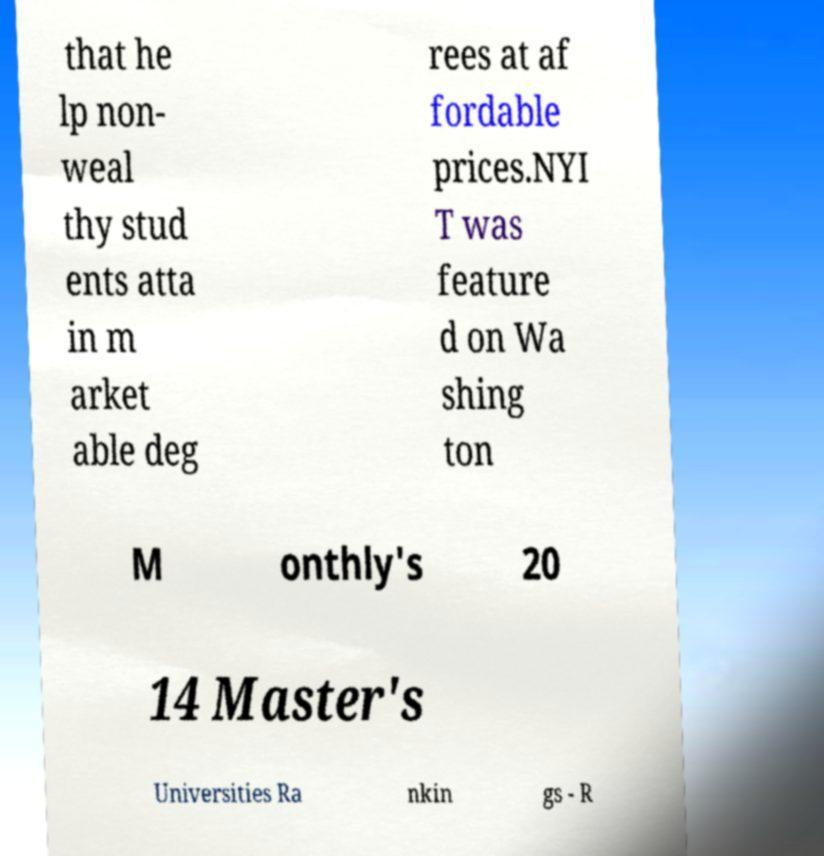For documentation purposes, I need the text within this image transcribed. Could you provide that? that he lp non- weal thy stud ents atta in m arket able deg rees at af fordable prices.NYI T was feature d on Wa shing ton M onthly's 20 14 Master's Universities Ra nkin gs - R 